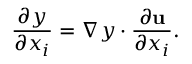<formula> <loc_0><loc_0><loc_500><loc_500>{ \frac { \partial y } { \partial x _ { i } } } = \nabla y \cdot { \frac { \partial u } { \partial x _ { i } } } .</formula> 